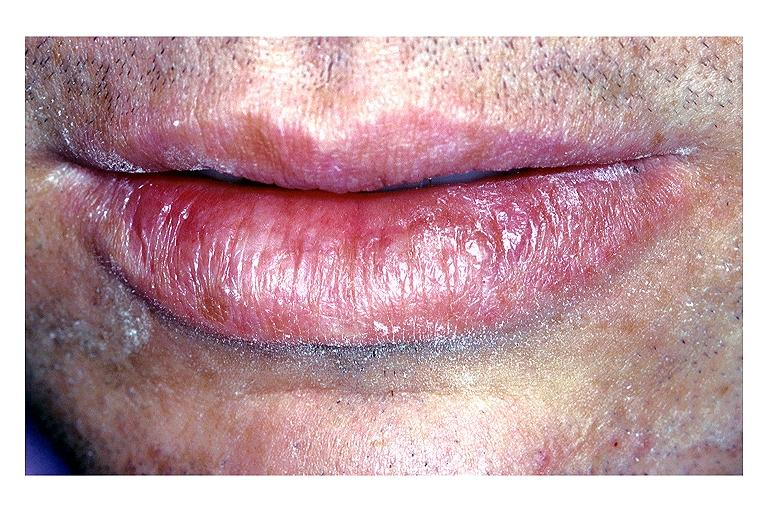does high excellent steroid show actinic keratosis?
Answer the question using a single word or phrase. No 